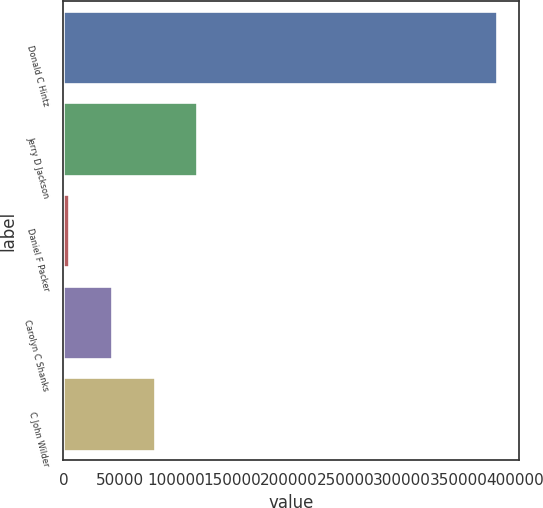<chart> <loc_0><loc_0><loc_500><loc_500><bar_chart><fcel>Donald C Hintz<fcel>Jerry D Jackson<fcel>Daniel F Packer<fcel>Carolyn C Shanks<fcel>C John Wilder<nl><fcel>384499<fcel>118803<fcel>4933<fcel>42889.6<fcel>80846.2<nl></chart> 